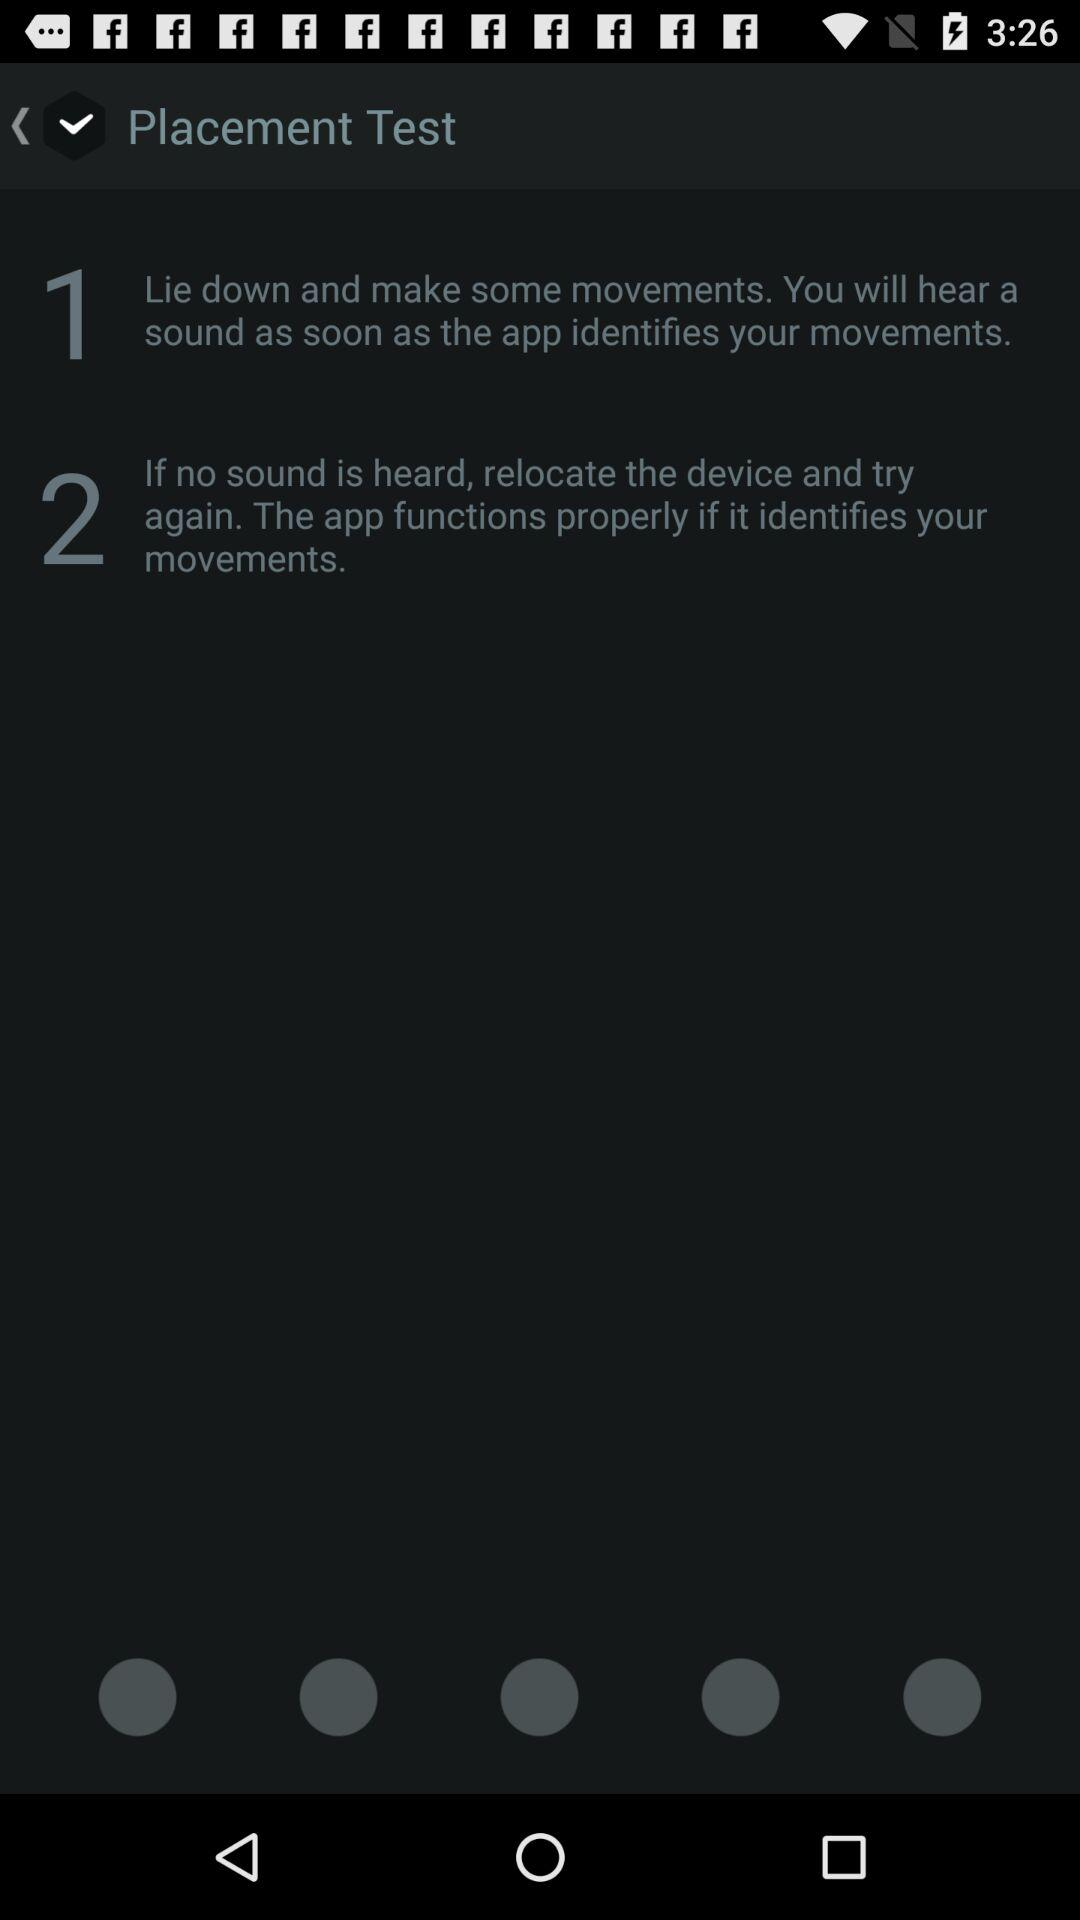What do we have to do if no sound is heard? If no sound is heard, you have to relocate the device and try again. 